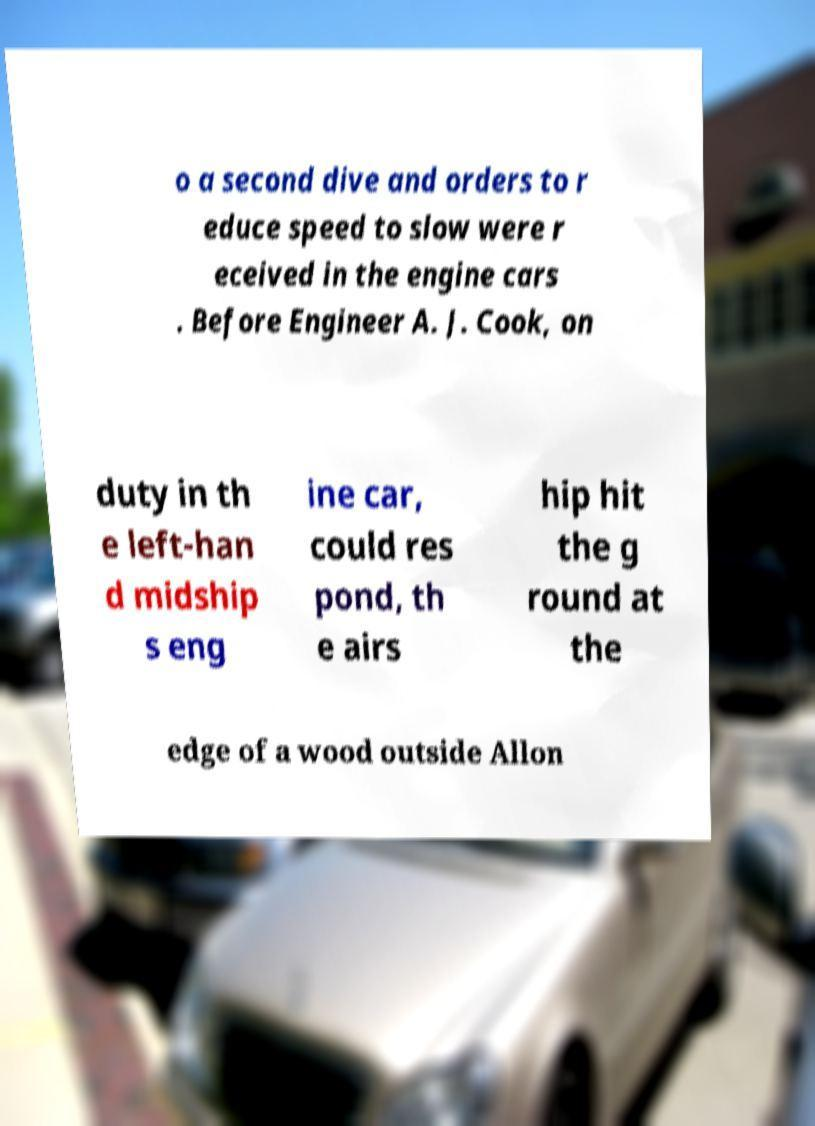Could you assist in decoding the text presented in this image and type it out clearly? o a second dive and orders to r educe speed to slow were r eceived in the engine cars . Before Engineer A. J. Cook, on duty in th e left-han d midship s eng ine car, could res pond, th e airs hip hit the g round at the edge of a wood outside Allon 